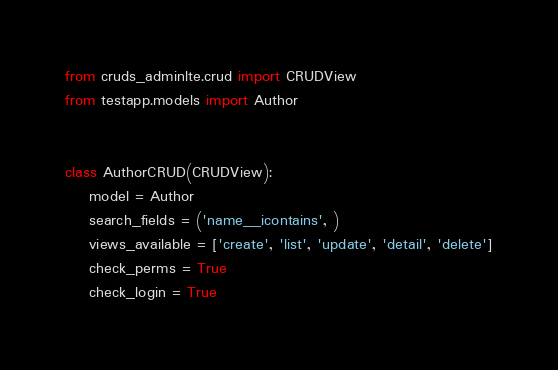Convert code to text. <code><loc_0><loc_0><loc_500><loc_500><_Python_>from cruds_adminlte.crud import CRUDView
from testapp.models import Author


class AuthorCRUD(CRUDView):
    model = Author
    search_fields = ('name__icontains', )
    views_available = ['create', 'list', 'update', 'detail', 'delete']
    check_perms = True
    check_login = True


</code> 